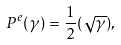Convert formula to latex. <formula><loc_0><loc_0><loc_500><loc_500>P ^ { e } ( \gamma ) = \frac { 1 } { 2 } ( \sqrt { \gamma } ) ,</formula> 